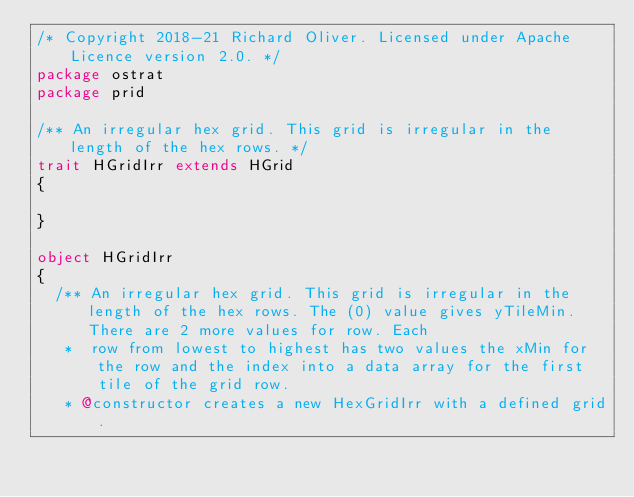Convert code to text. <code><loc_0><loc_0><loc_500><loc_500><_Scala_>/* Copyright 2018-21 Richard Oliver. Licensed under Apache Licence version 2.0. */
package ostrat
package prid

/** An irregular hex grid. This grid is irregular in the length of the hex rows. */
trait HGridIrr extends HGrid
{

}

object HGridIrr
{
  /** An irregular hex grid. This grid is irregular in the length of the hex rows. The (0) value gives yTileMin. There are 2 more values for row. Each
   *  row from lowest to highest has two values the xMin for the row and the index into a data array for the first tile of the grid row.
   * @constructor creates a new HexGridIrr with a defined grid.</code> 